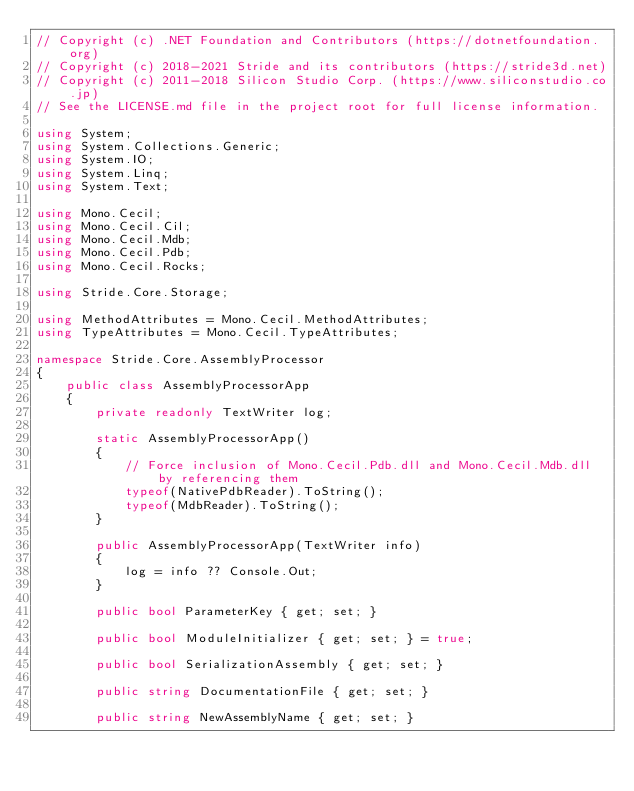Convert code to text. <code><loc_0><loc_0><loc_500><loc_500><_C#_>// Copyright (c) .NET Foundation and Contributors (https://dotnetfoundation.org)
// Copyright (c) 2018-2021 Stride and its contributors (https://stride3d.net)
// Copyright (c) 2011-2018 Silicon Studio Corp. (https://www.siliconstudio.co.jp)
// See the LICENSE.md file in the project root for full license information.

using System;
using System.Collections.Generic;
using System.IO;
using System.Linq;
using System.Text;

using Mono.Cecil;
using Mono.Cecil.Cil;
using Mono.Cecil.Mdb;
using Mono.Cecil.Pdb;
using Mono.Cecil.Rocks;

using Stride.Core.Storage;

using MethodAttributes = Mono.Cecil.MethodAttributes;
using TypeAttributes = Mono.Cecil.TypeAttributes;

namespace Stride.Core.AssemblyProcessor
{
    public class AssemblyProcessorApp
    {
        private readonly TextWriter log;

        static AssemblyProcessorApp()
        {
            // Force inclusion of Mono.Cecil.Pdb.dll and Mono.Cecil.Mdb.dll by referencing them
            typeof(NativePdbReader).ToString();
            typeof(MdbReader).ToString();
        }

        public AssemblyProcessorApp(TextWriter info)
        {
            log = info ?? Console.Out;
        }

        public bool ParameterKey { get; set; }

        public bool ModuleInitializer { get; set; } = true;

        public bool SerializationAssembly { get; set; }

        public string DocumentationFile { get; set; }

        public string NewAssemblyName { get; set; }
</code> 